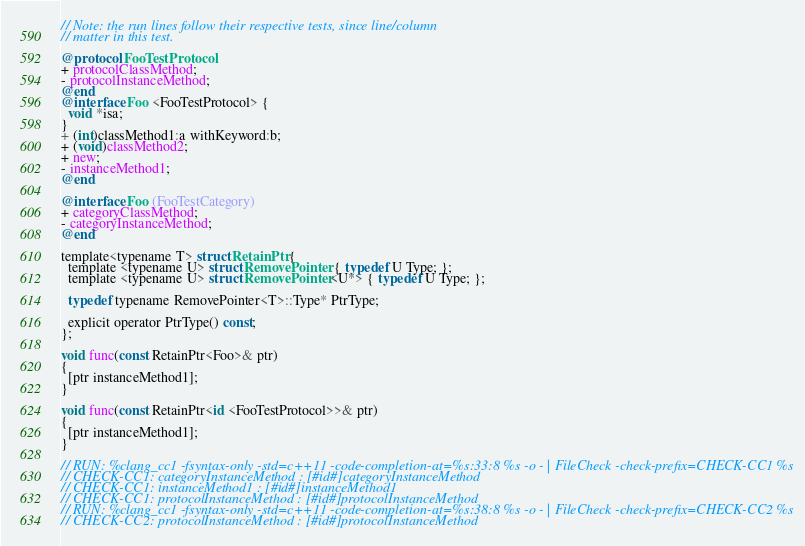<code> <loc_0><loc_0><loc_500><loc_500><_ObjectiveC_>// Note: the run lines follow their respective tests, since line/column
// matter in this test.

@protocol FooTestProtocol
+ protocolClassMethod;
- protocolInstanceMethod;
@end
@interface Foo <FooTestProtocol> {
  void *isa;
}
+ (int)classMethod1:a withKeyword:b;
+ (void)classMethod2;
+ new;
- instanceMethod1;
@end

@interface Foo (FooTestCategory)
+ categoryClassMethod;
- categoryInstanceMethod;
@end

template<typename T> struct RetainPtr {
  template <typename U> struct RemovePointer { typedef U Type; };
  template <typename U> struct RemovePointer<U*> { typedef U Type; };
    
  typedef typename RemovePointer<T>::Type* PtrType;

  explicit operator PtrType() const;
};

void func(const RetainPtr<Foo>& ptr)
{
  [ptr instanceMethod1];
}

void func(const RetainPtr<id <FooTestProtocol>>& ptr)
{
  [ptr instanceMethod1];
}

// RUN: %clang_cc1 -fsyntax-only -std=c++11 -code-completion-at=%s:33:8 %s -o - | FileCheck -check-prefix=CHECK-CC1 %s
// CHECK-CC1: categoryInstanceMethod : [#id#]categoryInstanceMethod
// CHECK-CC1: instanceMethod1 : [#id#]instanceMethod1
// CHECK-CC1: protocolInstanceMethod : [#id#]protocolInstanceMethod
// RUN: %clang_cc1 -fsyntax-only -std=c++11 -code-completion-at=%s:38:8 %s -o - | FileCheck -check-prefix=CHECK-CC2 %s
// CHECK-CC2: protocolInstanceMethod : [#id#]protocolInstanceMethod
</code> 